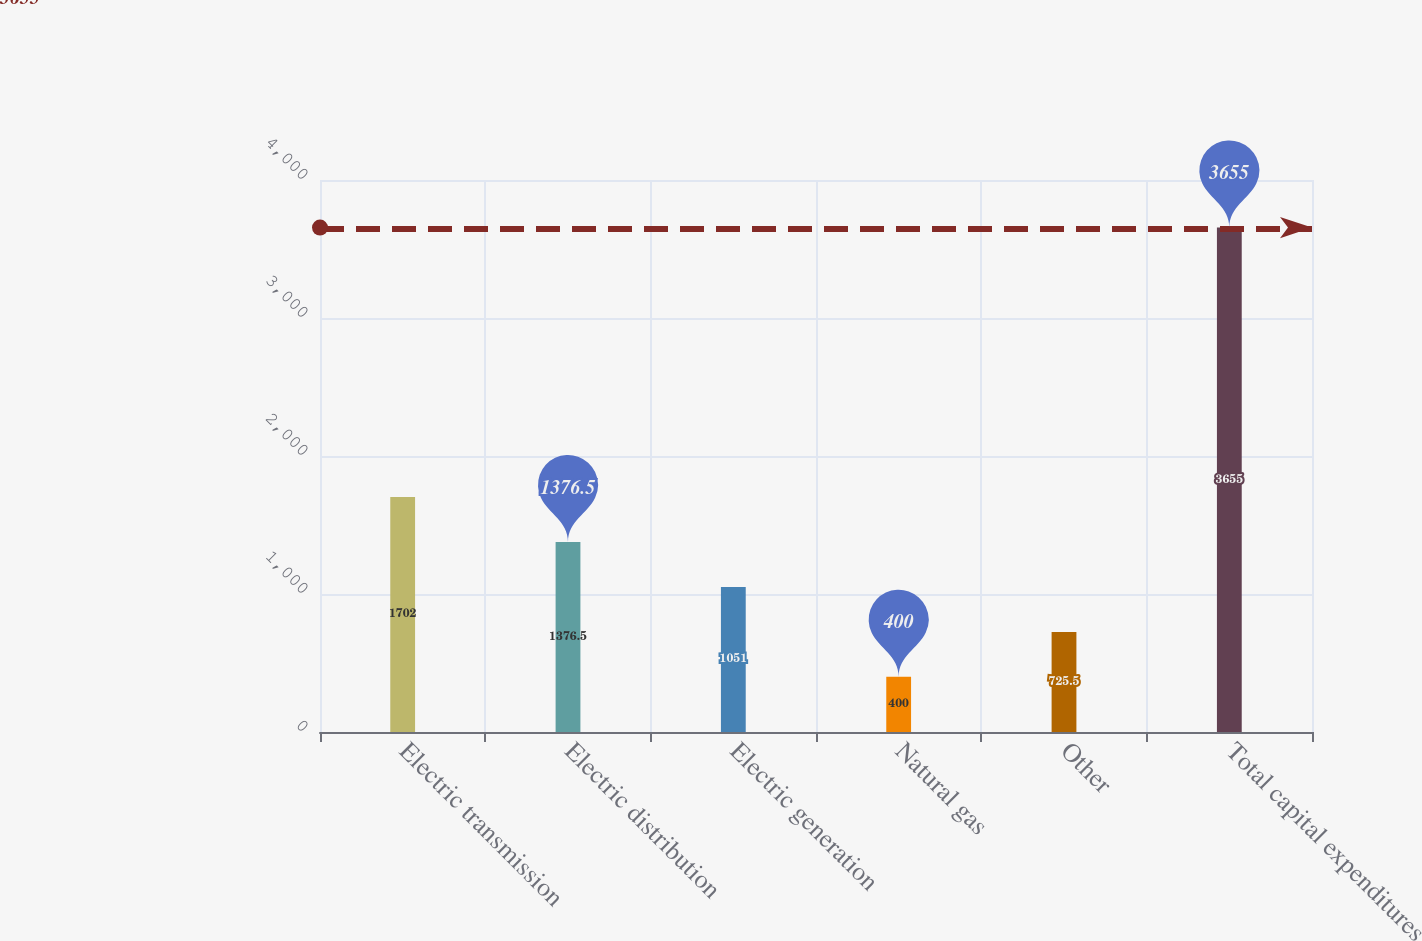Convert chart to OTSL. <chart><loc_0><loc_0><loc_500><loc_500><bar_chart><fcel>Electric transmission<fcel>Electric distribution<fcel>Electric generation<fcel>Natural gas<fcel>Other<fcel>Total capital expenditures<nl><fcel>1702<fcel>1376.5<fcel>1051<fcel>400<fcel>725.5<fcel>3655<nl></chart> 